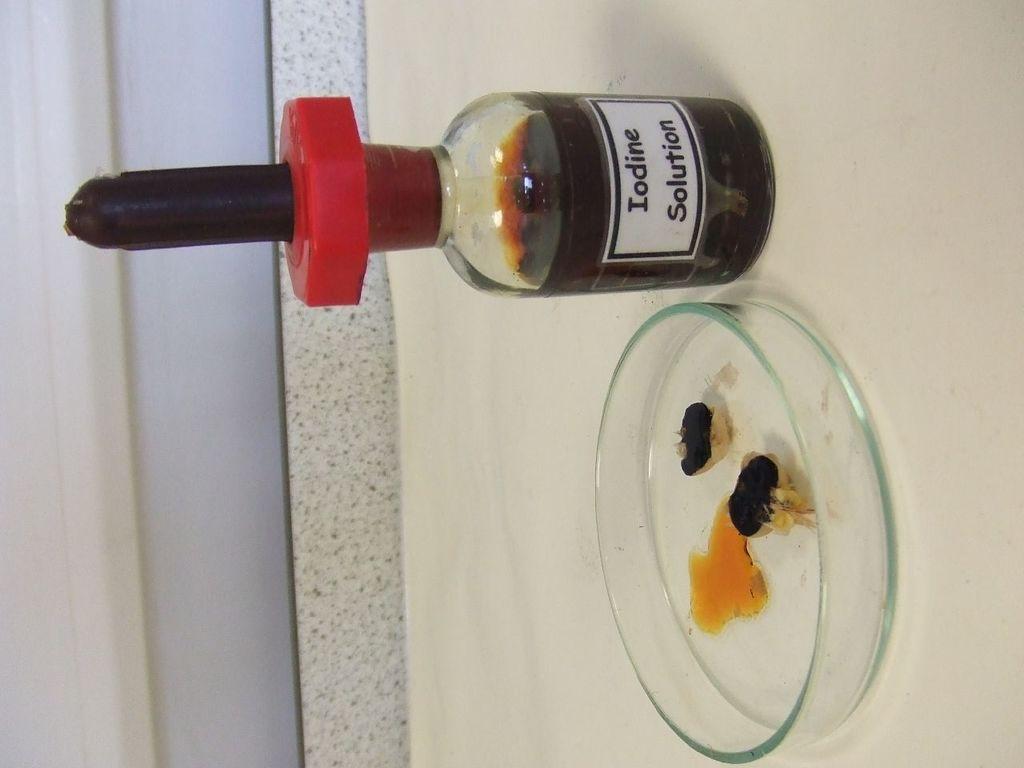Could you give a brief overview of what you see in this image? In the image there is iodine solution and glass tray beside it on a floor. 